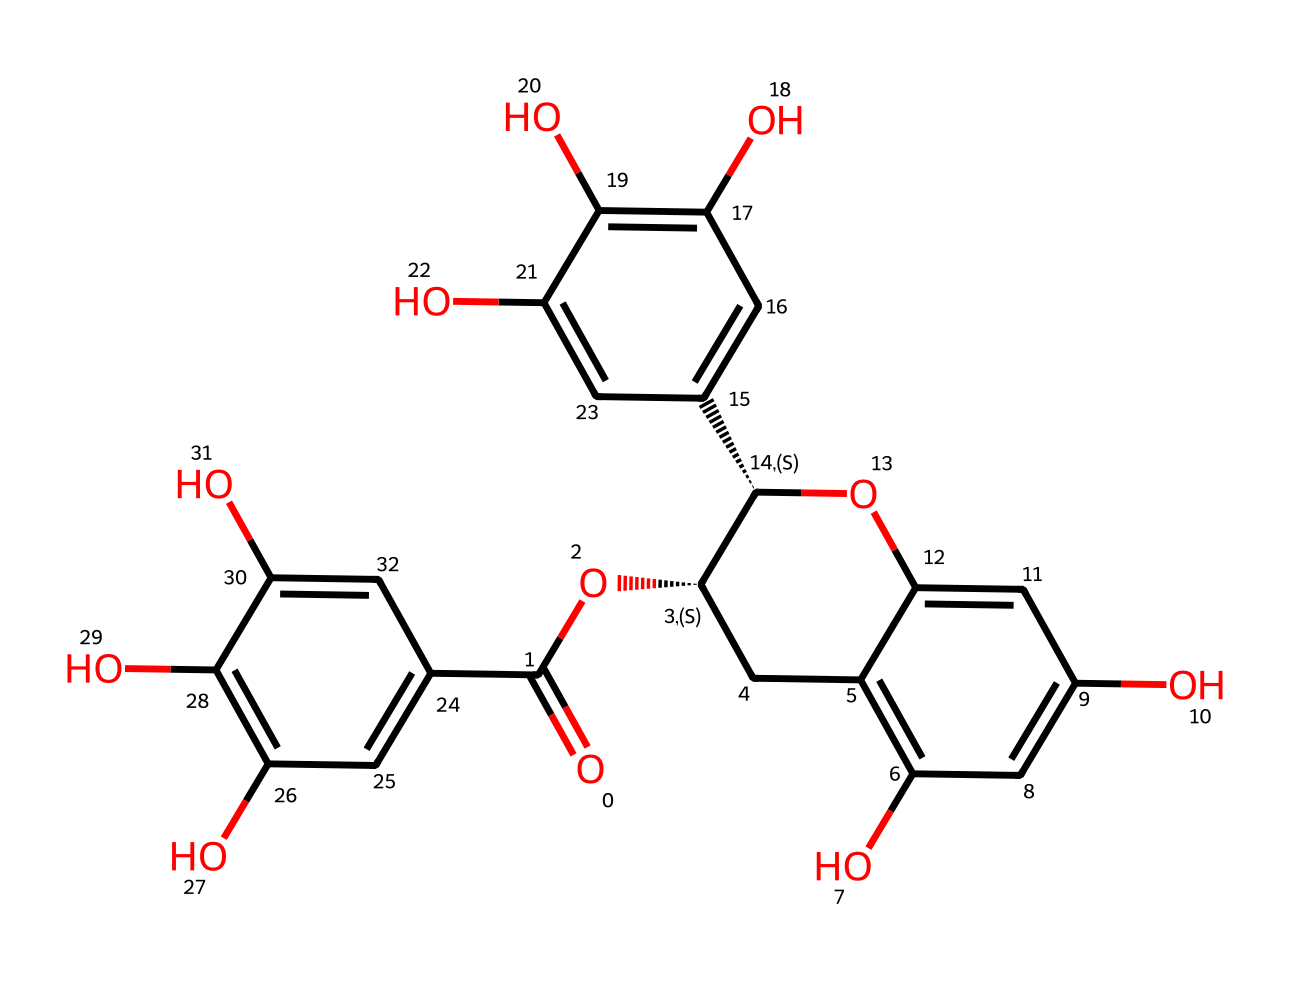What is the molecular formula of EGCG? By analyzing the structure represented by the SMILES, we can count the atoms present: 21 carbons, 18 hydrogens, and 10 oxygens. Therefore, the molecular formula deduced from these counts is C21H18O10.
Answer: C21H18O10 How many hydroxyl groups are present in EGCG? Observing the structure, we can identify the hydroxyl groups (-OH): there are a total of 5 hydroxyl groups attached to the aromatic rings.
Answer: 5 What is the main functional group present in EGCG? Looking at the structure, the predominant feature is the phenolic hydroxyl groups, which characterize EGCG as a polyphenol. Therefore, the main functional group is the phenolic group.
Answer: phenolic group What type of chemical is EGCG classified as? Based on its structure, which contains multiple phenol units and antioxidant properties, EGCG is classified as a flavonoid, specifically a catechin.
Answer: flavonoid Which part of the chemical structure contributes most to its antioxidant properties? The presence of multiple hydroxyl groups on the aromatic rings plays a significant role in donating electrons and neutralizing free radicals, which is crucial for its antioxidant activity.
Answer: hydroxyl groups 